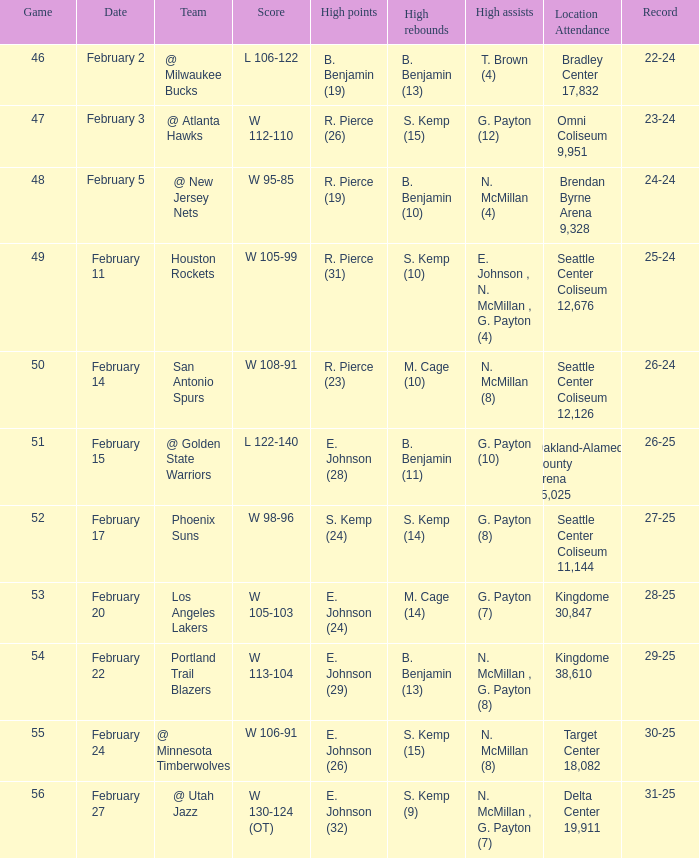Who had the high points when the score was w 112-110? R. Pierce (26). 